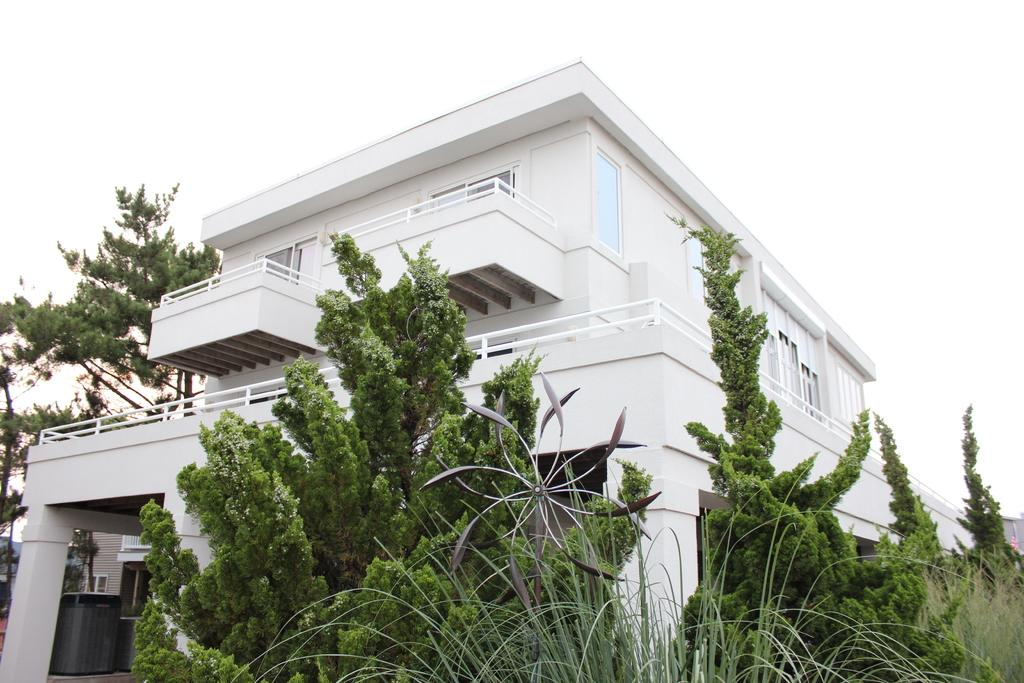What type of structure is visible in the image? There is a house in the image. What architectural features can be seen in the house? The house has walls, windows, and pillars. What other objects are present in the image? There are rods, a dustbin, and plants visible at the bottom of the image. What can be seen in the background of the image? The sky, trees, another house, a window, a pole, and a wall are visible in the background of the image. How many hills can be seen in the image? There are no hills visible in the image. What type of woodworking tool is the carpenter using in the image? There is no carpenter or woodworking tool present in the image. 